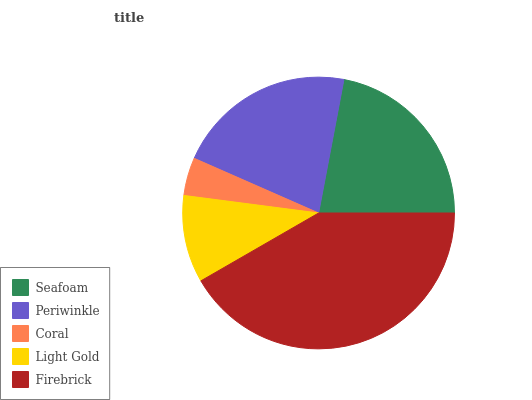Is Coral the minimum?
Answer yes or no. Yes. Is Firebrick the maximum?
Answer yes or no. Yes. Is Periwinkle the minimum?
Answer yes or no. No. Is Periwinkle the maximum?
Answer yes or no. No. Is Seafoam greater than Periwinkle?
Answer yes or no. Yes. Is Periwinkle less than Seafoam?
Answer yes or no. Yes. Is Periwinkle greater than Seafoam?
Answer yes or no. No. Is Seafoam less than Periwinkle?
Answer yes or no. No. Is Periwinkle the high median?
Answer yes or no. Yes. Is Periwinkle the low median?
Answer yes or no. Yes. Is Firebrick the high median?
Answer yes or no. No. Is Coral the low median?
Answer yes or no. No. 